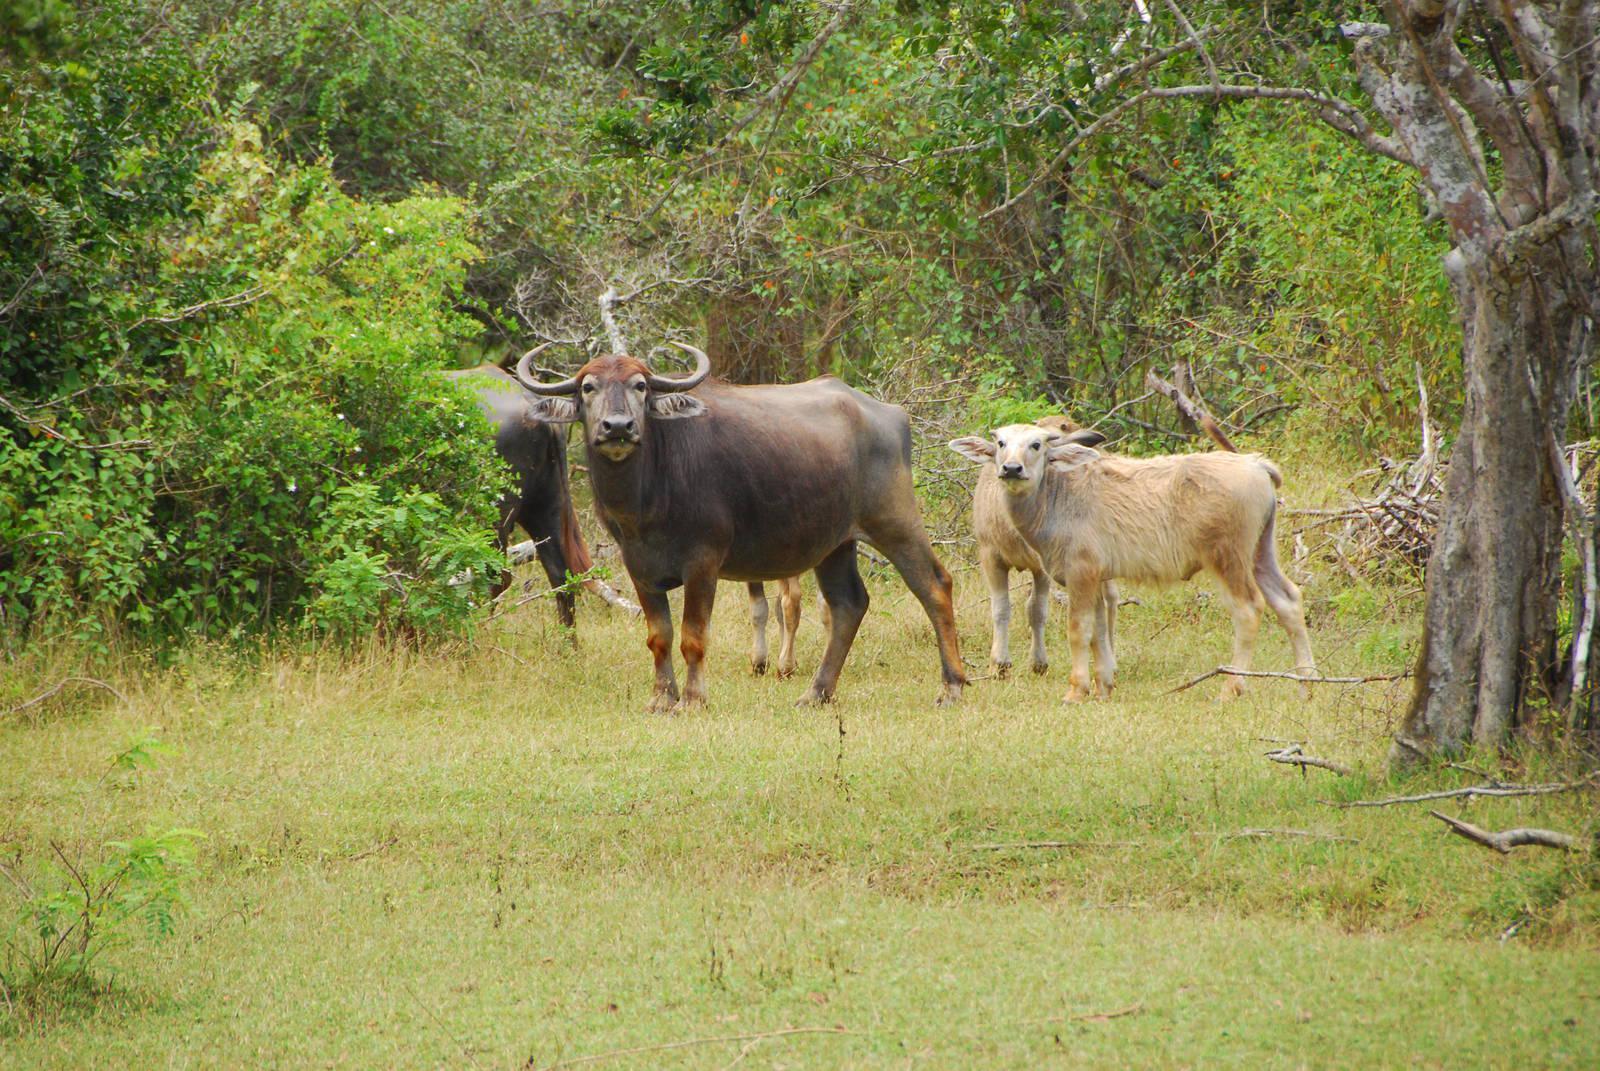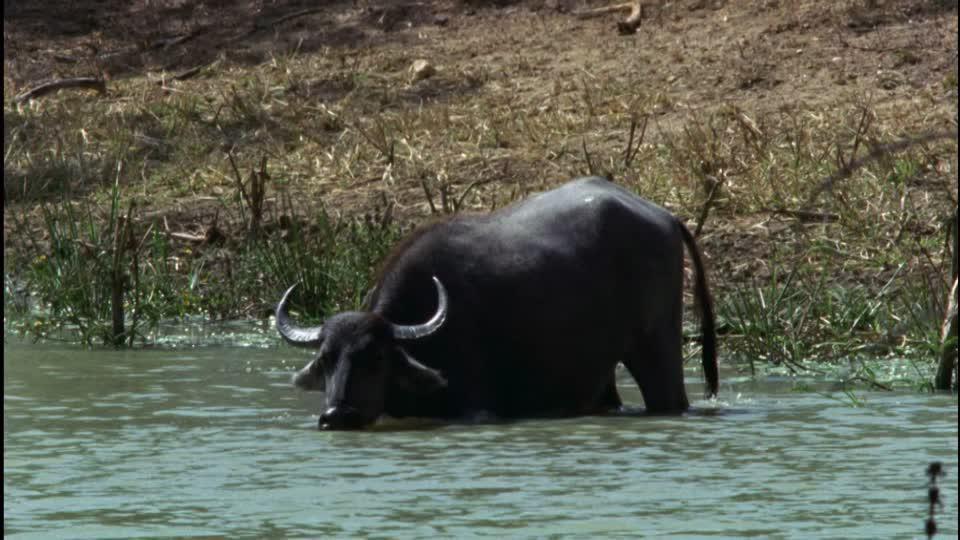The first image is the image on the left, the second image is the image on the right. Examine the images to the left and right. Is the description "Two animals are standing in the water." accurate? Answer yes or no. No. 